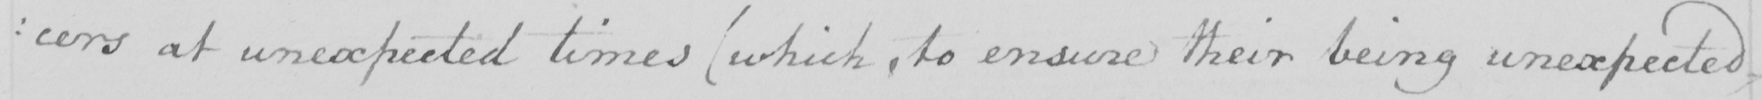Transcribe the text shown in this historical manuscript line. :cers at unexpected times (which, to ensure their being unexpected, 